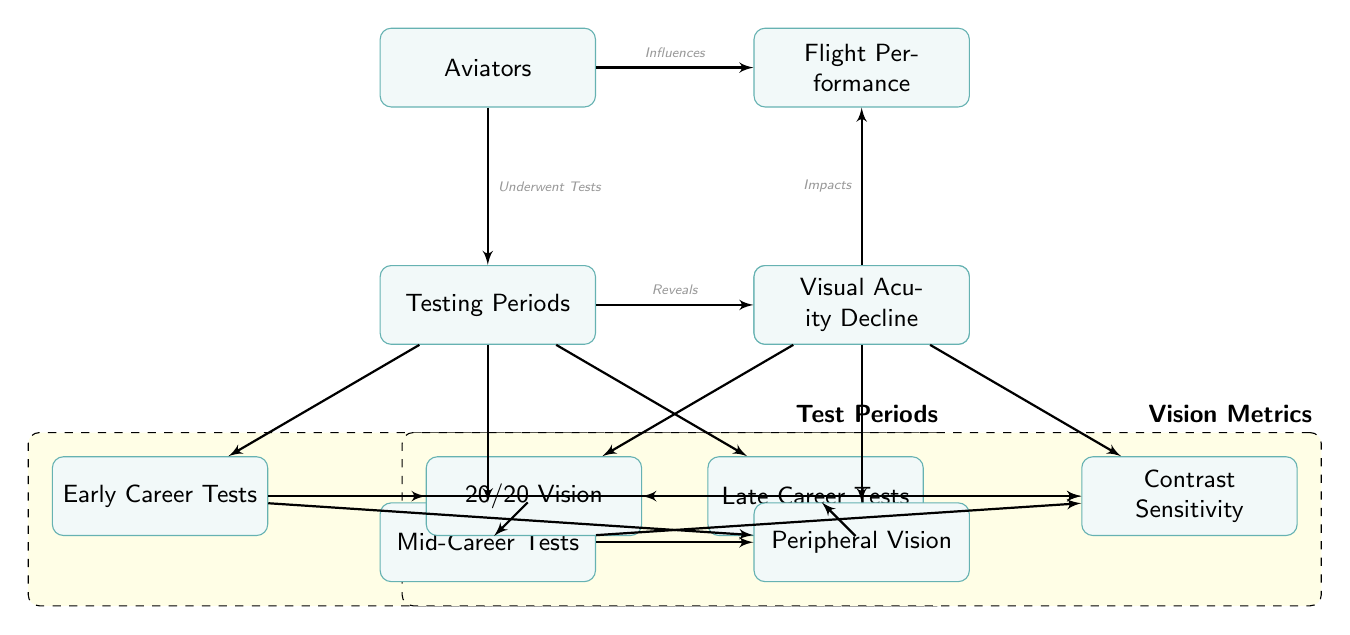What are the three testing periods shown in the diagram? The diagram explicitly lists three testing periods for aviators which are "Early Career Tests," "Mid-Career Tests," and "Late Career Tests."
Answer: Early Career Tests, Mid-Career Tests, Late Career Tests How many vision metrics are illustrated in the diagram? The diagram shows three distinct vision metrics: "20/20 Vision," "Peripheral Vision," and "Contrast Sensitivity," making a total of three metrics.
Answer: 3 What influences flight performance according to the diagram? The diagram indicates that the node "Aviators" influences "Flight Performance," and additionally, "Visual Acuity Decline" also impacts "Flight Performance."
Answer: Aviators, Visual Acuity Decline Which vision metric visually connects to "Mid-Career Tests"? The diagram displays connections from "Mid-Career Tests" to all three vision metrics: "20/20 Vision," "Peripheral Vision," and "Contrast Sensitivity." These all visually link to the mid-career node.
Answer: 20/20 Vision, Peripheral Vision, Contrast Sensitivity What relationship is shown between testing periods and visual acuity decline? The diagram explicitly illustrates that "Testing Periods" reveals "Visual Acuity Decline," suggesting that as testing occurs over time, a decline in visual acuity can be observed.
Answer: Reveals Which node is positioned directly below "Flight Performance"? There is only one node directly below "Flight Performance," which is "Visual Acuity Decline." This connection indicates that the decline in visual acuity is considered for flight performance.
Answer: Visual Acuity Decline 